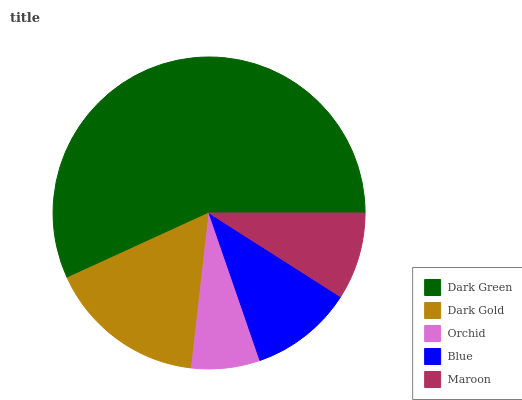Is Orchid the minimum?
Answer yes or no. Yes. Is Dark Green the maximum?
Answer yes or no. Yes. Is Dark Gold the minimum?
Answer yes or no. No. Is Dark Gold the maximum?
Answer yes or no. No. Is Dark Green greater than Dark Gold?
Answer yes or no. Yes. Is Dark Gold less than Dark Green?
Answer yes or no. Yes. Is Dark Gold greater than Dark Green?
Answer yes or no. No. Is Dark Green less than Dark Gold?
Answer yes or no. No. Is Blue the high median?
Answer yes or no. Yes. Is Blue the low median?
Answer yes or no. Yes. Is Dark Green the high median?
Answer yes or no. No. Is Orchid the low median?
Answer yes or no. No. 